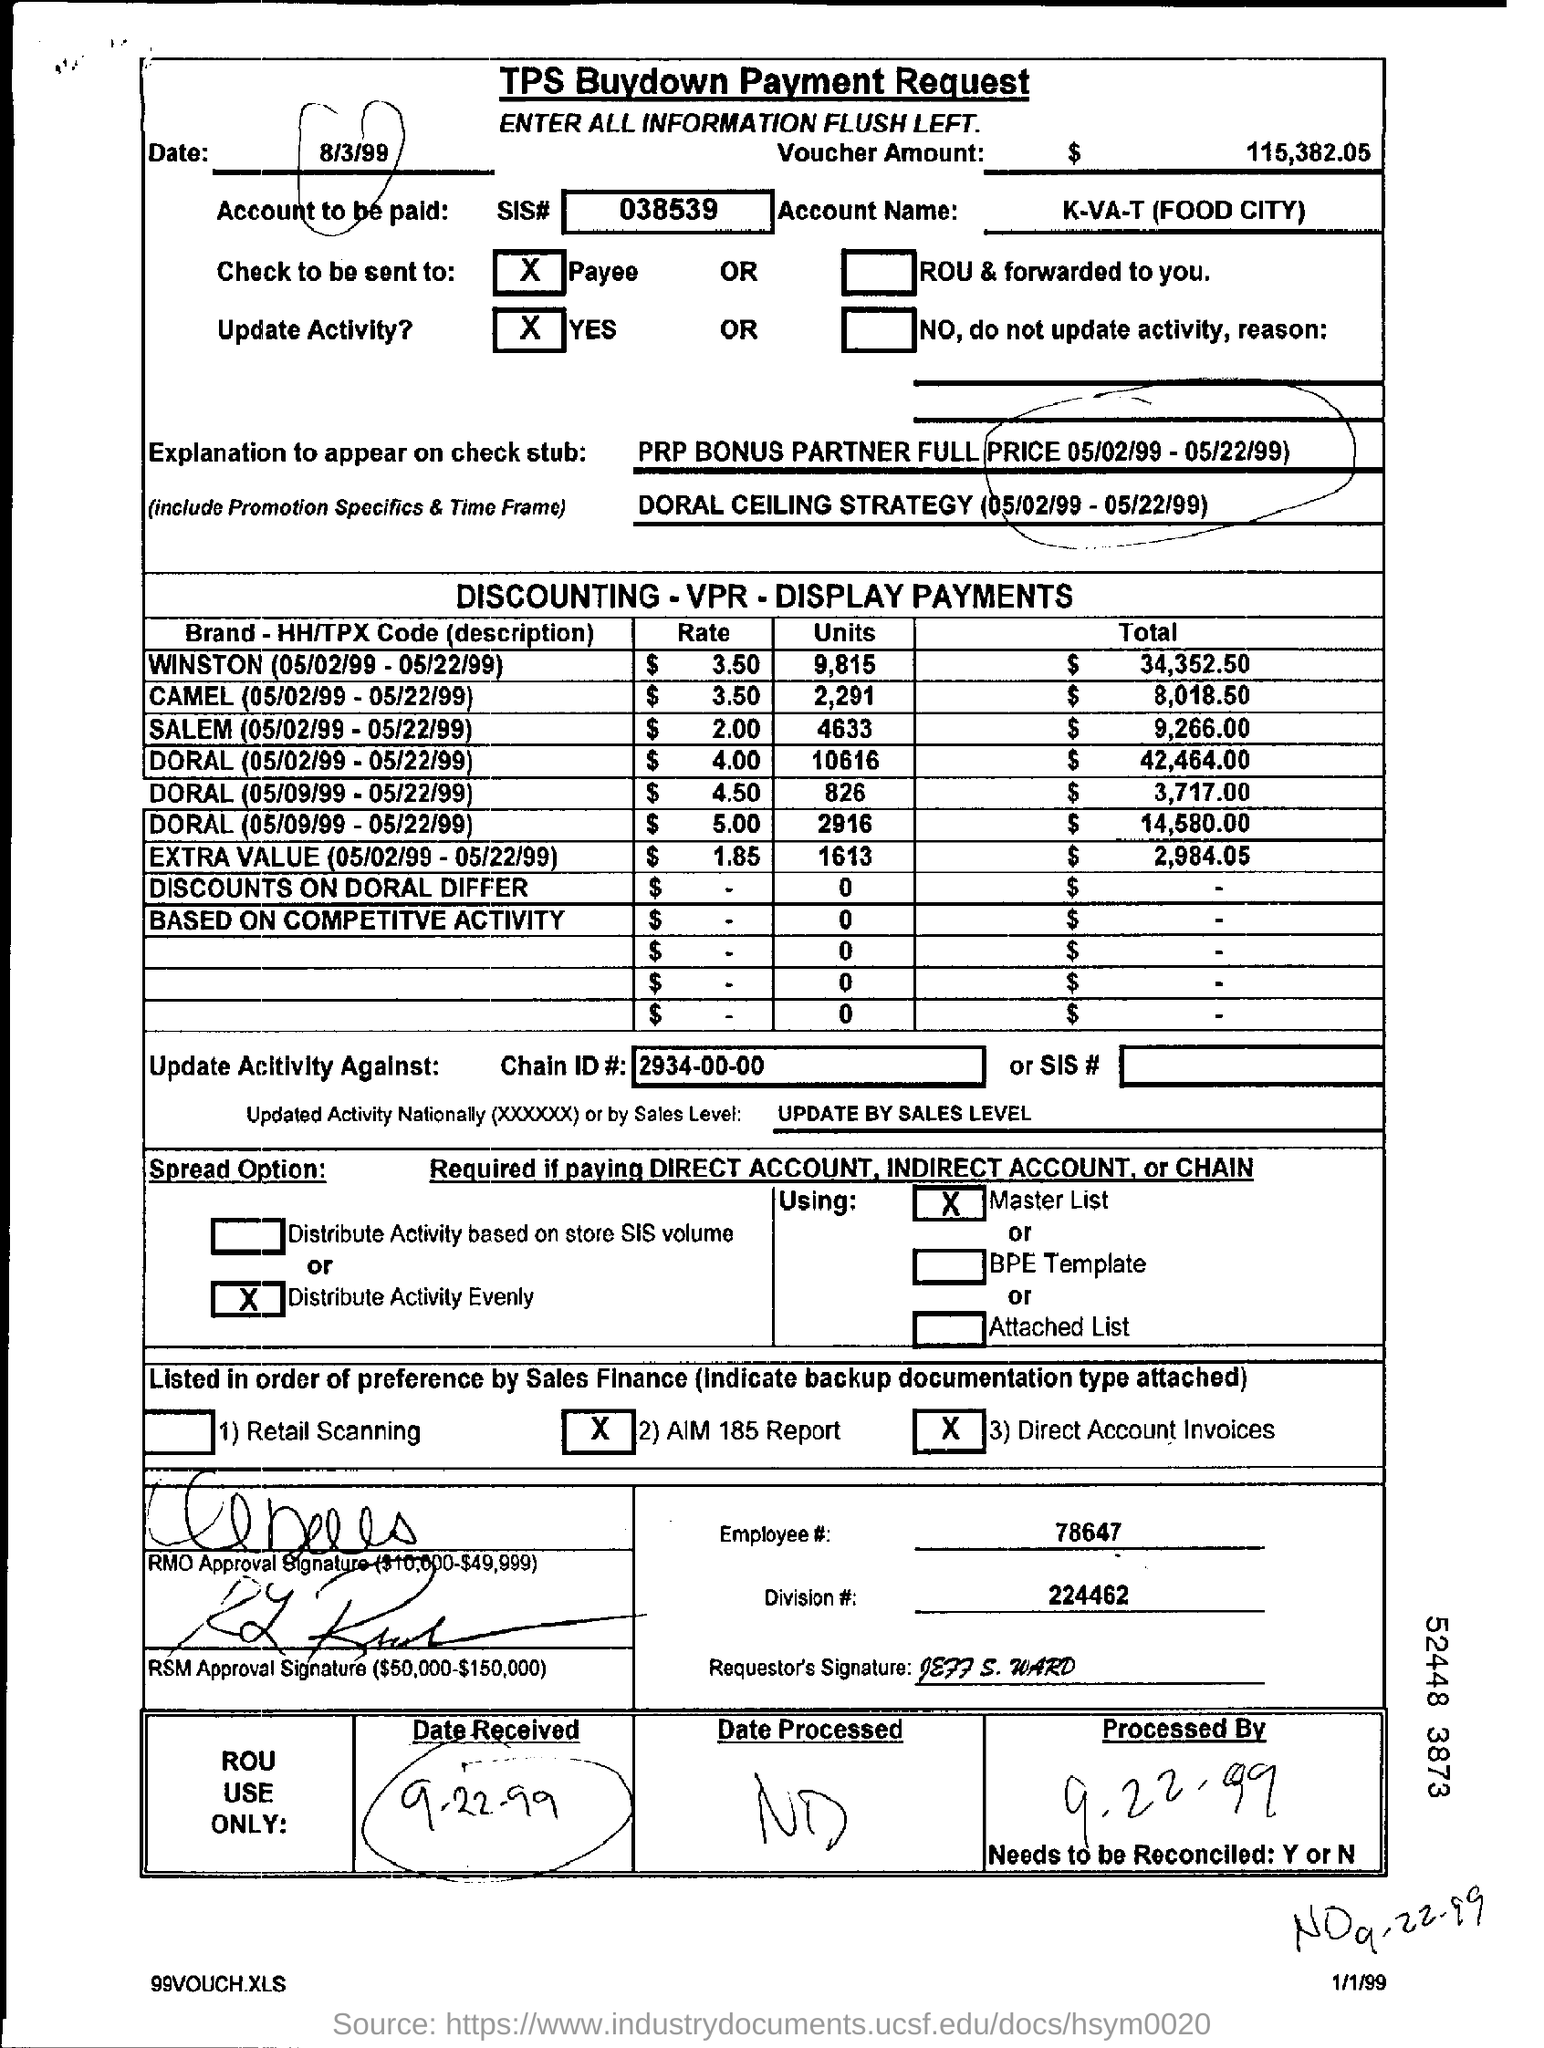Can you tell me what this document is used for? This image appears to be of a TPS Buydown Payment Request form, which is used to record and request payments related to promotional discounts and sales strategies within a retail setting. What is the total voucher amount on the document? The total voucher amount listed on this document is $115,382.05. 